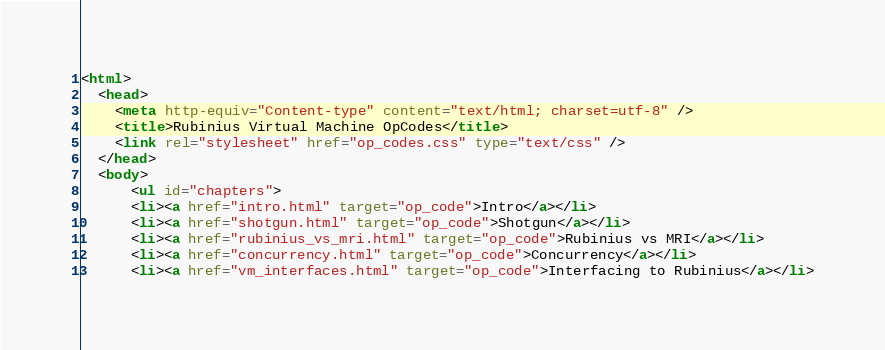Convert code to text. <code><loc_0><loc_0><loc_500><loc_500><_HTML_><html>
  <head>
    <meta http-equiv="Content-type" content="text/html; charset=utf-8" />
    <title>Rubinius Virtual Machine OpCodes</title>
    <link rel="stylesheet" href="op_codes.css" type="text/css" />
  </head>
  <body>
	  <ul id="chapters">
      <li><a href="intro.html" target="op_code">Intro</a></li>
      <li><a href="shotgun.html" target="op_code">Shotgun</a></li>
      <li><a href="rubinius_vs_mri.html" target="op_code">Rubinius vs MRI</a></li>
      <li><a href="concurrency.html" target="op_code">Concurrency</a></li>
      <li><a href="vm_interfaces.html" target="op_code">Interfacing to Rubinius</a></li></code> 